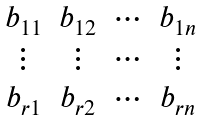<formula> <loc_0><loc_0><loc_500><loc_500>\begin{matrix} b _ { 1 1 } & b _ { 1 2 } & \cdots & b _ { 1 n } \\ \vdots & \vdots & \cdots & \vdots \\ b _ { r 1 } & b _ { r 2 } & \cdots & b _ { r n } \\ \end{matrix}</formula> 